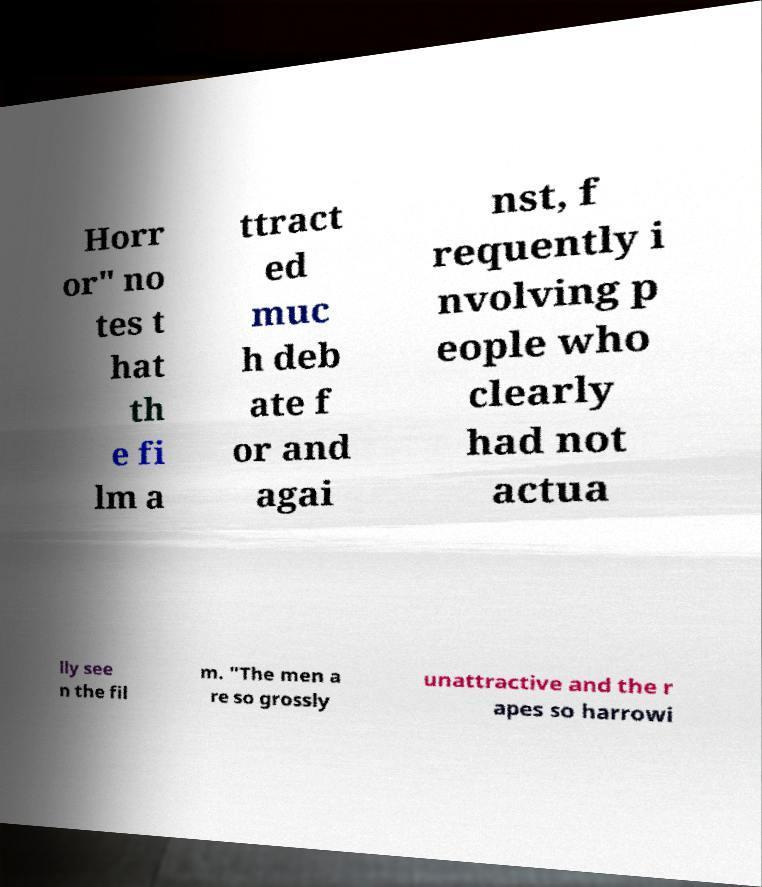Could you assist in decoding the text presented in this image and type it out clearly? Horr or" no tes t hat th e fi lm a ttract ed muc h deb ate f or and agai nst, f requently i nvolving p eople who clearly had not actua lly see n the fil m. "The men a re so grossly unattractive and the r apes so harrowi 